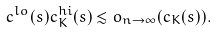Convert formula to latex. <formula><loc_0><loc_0><loc_500><loc_500>c ^ { l o } ( s ) c ^ { h i } _ { K } ( s ) \lesssim o _ { n \to \infty } ( c _ { K } ( s ) ) .</formula> 